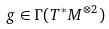Convert formula to latex. <formula><loc_0><loc_0><loc_500><loc_500>g \in \Gamma ( T ^ { * } M ^ { \otimes 2 } )</formula> 